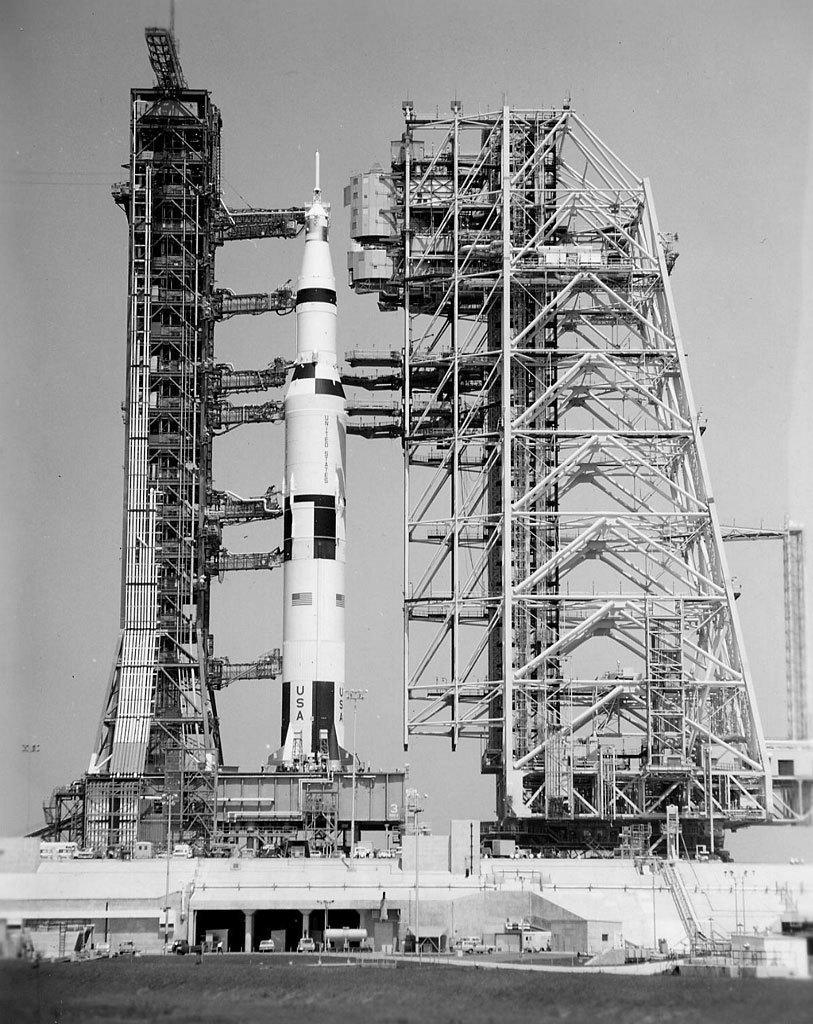Describe this image in one or two sentences. In the foreground I can see a group of people and vehicles on the road. In the background I can see a fence, metal rods, missile launching machine and the sky. This image is taken on the ground. 